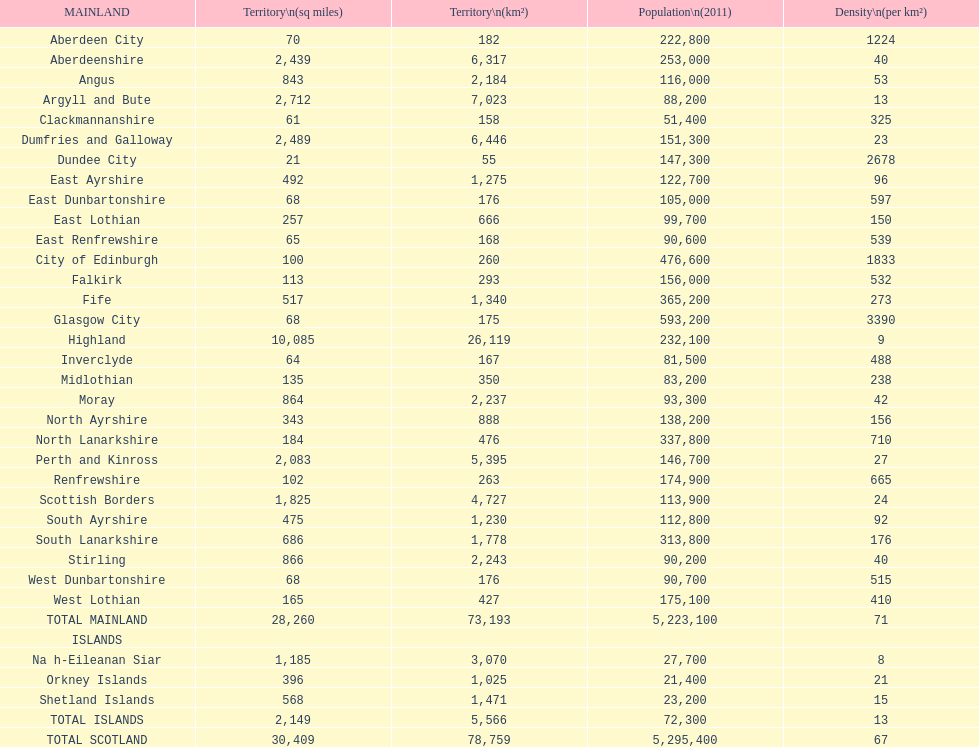Which mainland has the least population? Clackmannanshire. 